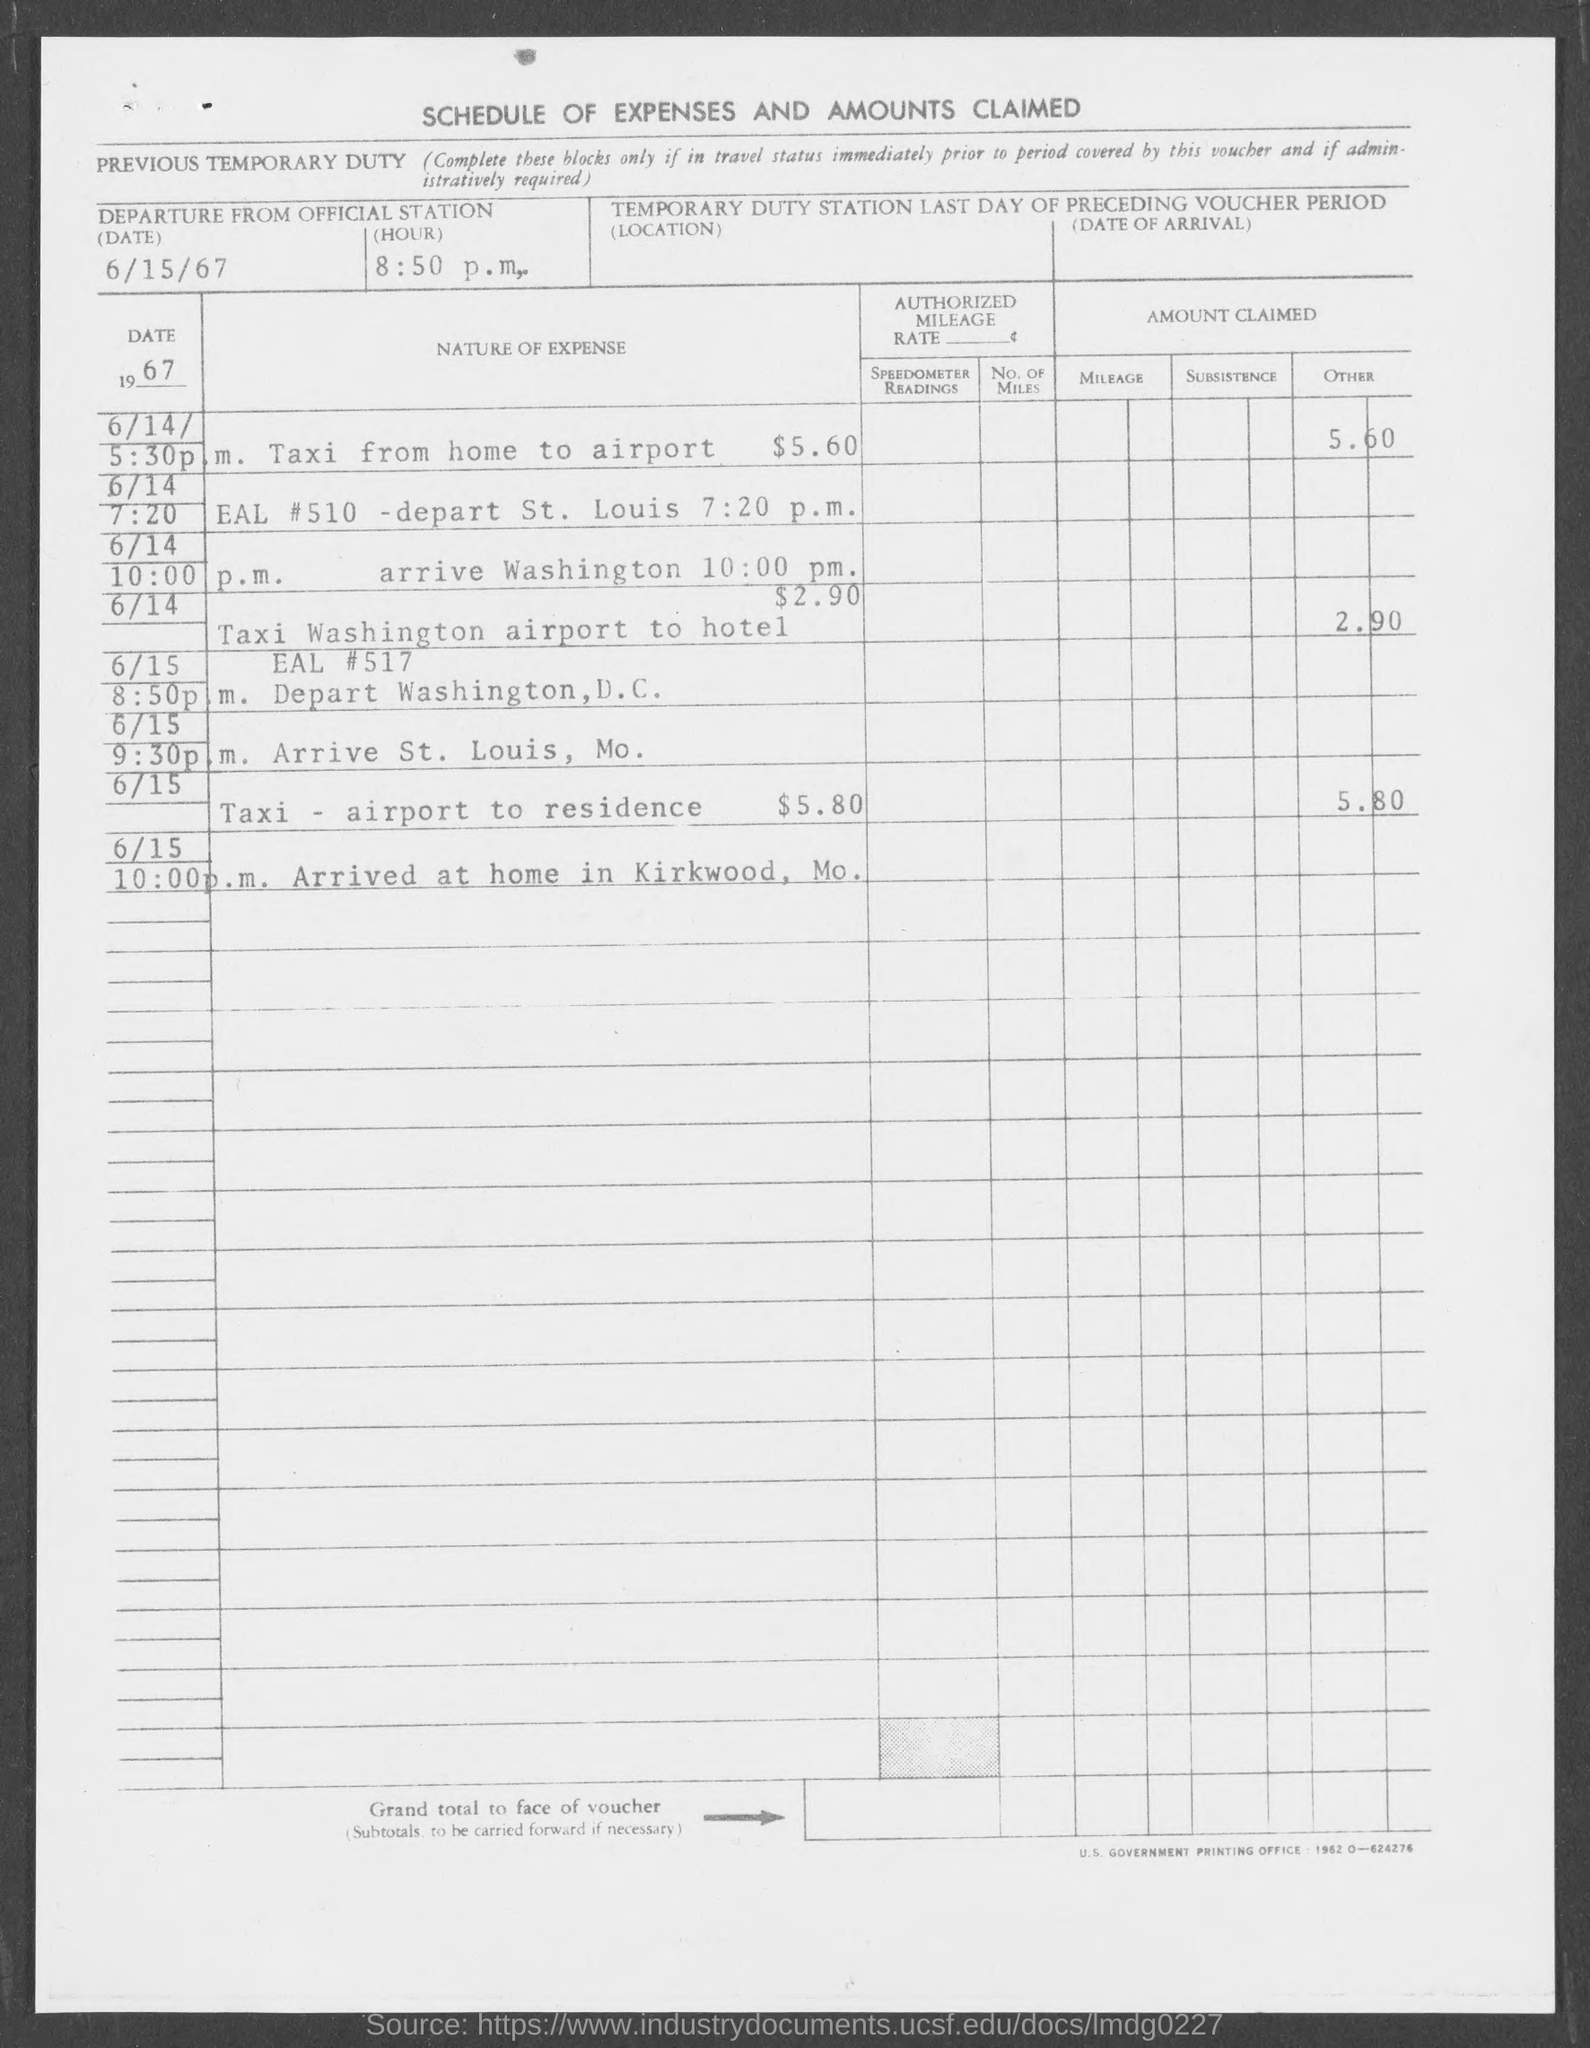Specify some key components in this picture. The title of this document is Schedule of Expenses and Amounts Claimed. The departure date from the official station is June 15th, 1967. The time of departure from the official station is 8:50 p.m. 